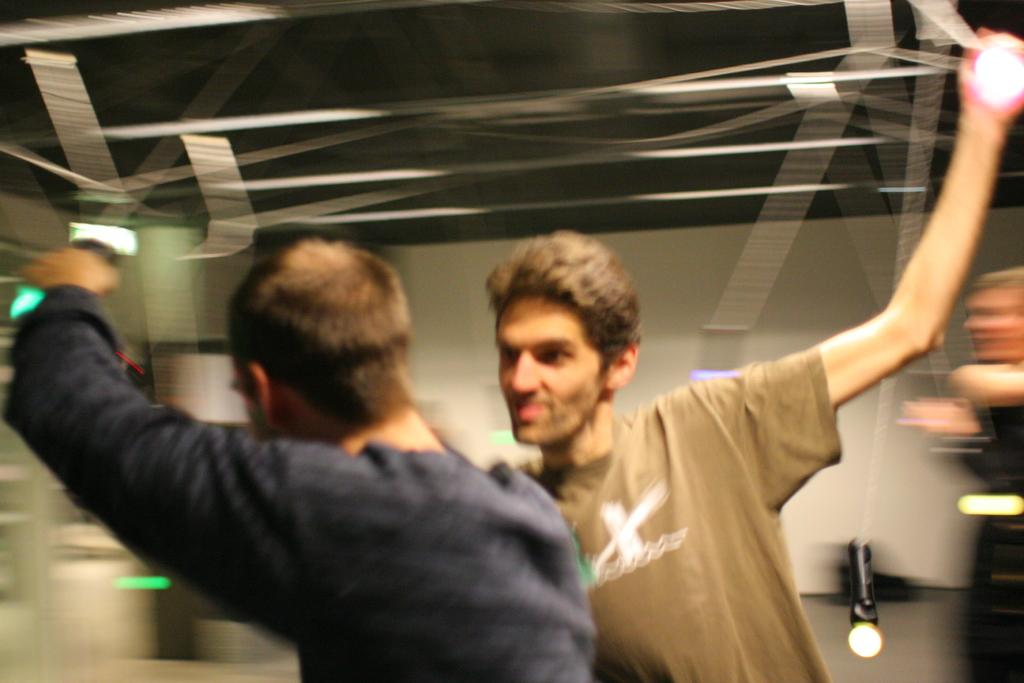Who or what can be seen in the image? There are people in the image. What can be observed in terms of illumination in the image? There are lights in the image. What else is present in the image besides people and lights? There are objects in the image. What type of soup is being served in the image? There is no soup present in the image. What kind of apparatus is being used by the people in the image? There is no apparatus visible in the image; the people are not using any specific tools or equipment. 